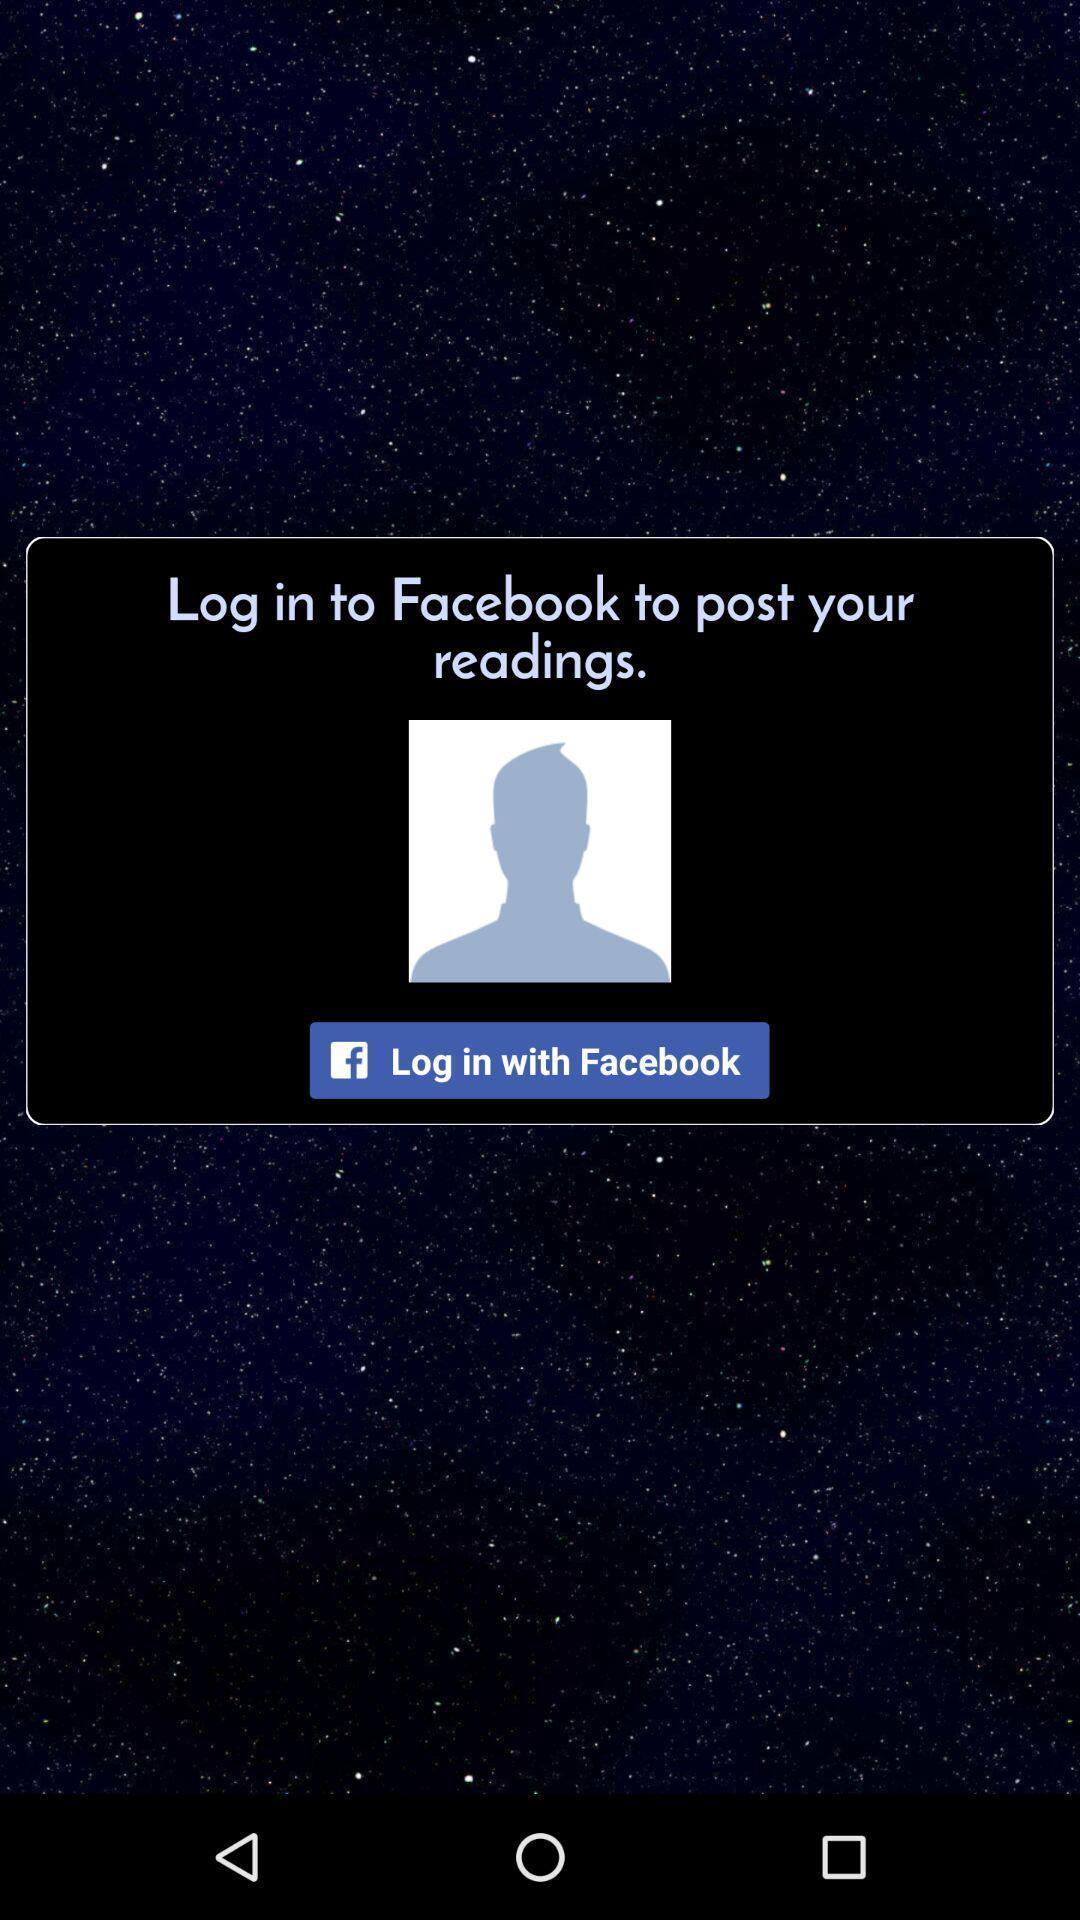Describe the content in this image. Welcome page of a social application. 